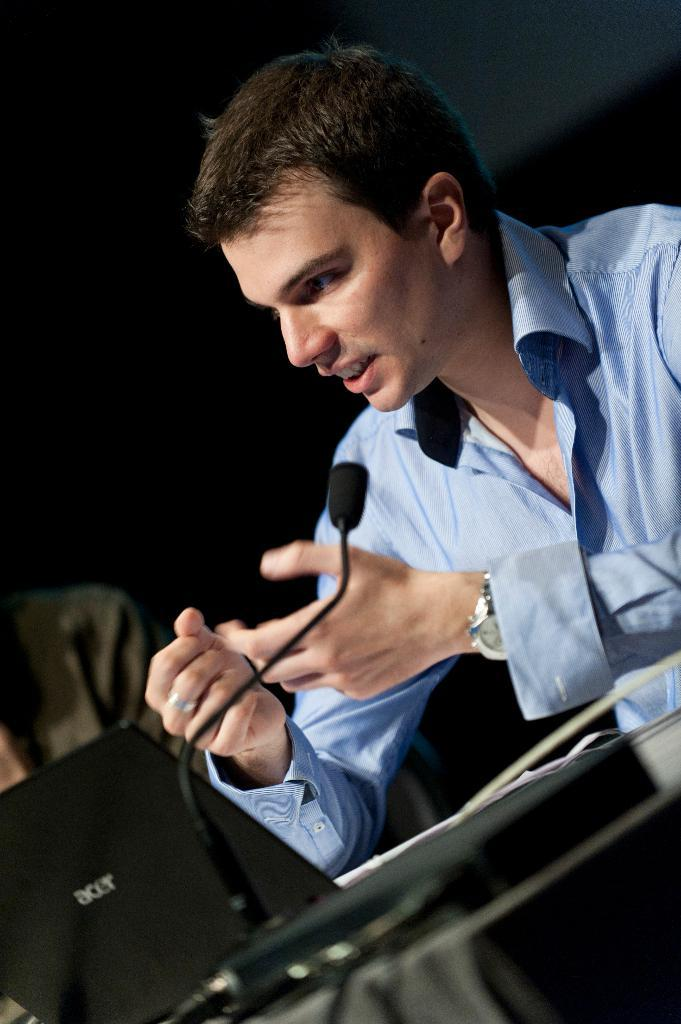Who is present in the image? There is a man in the image. What is the man wearing on his upper body? The man is wearing a blue shirt. What accessory is the man wearing on his wrist? The man is wearing a watch. What electronic device is in front of the man? There is a laptop in front of front of the man. What communication tool is in front of the man? There is a mic in front of the man. What type of flame can be seen coming from the laptop in the image? There is no flame present in the image; the laptop is not on fire. 